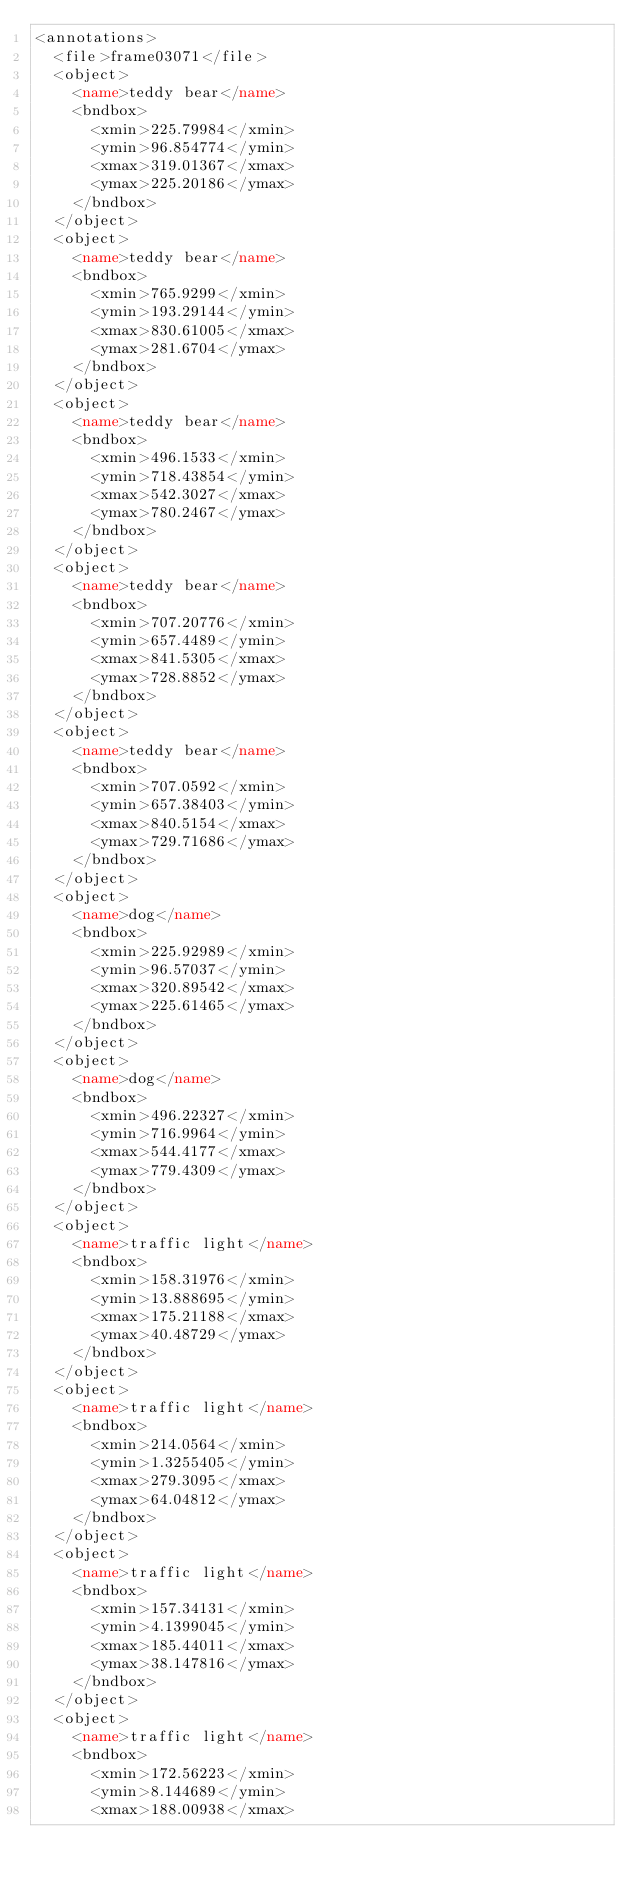<code> <loc_0><loc_0><loc_500><loc_500><_XML_><annotations>
  <file>frame03071</file>
  <object>
    <name>teddy bear</name>
    <bndbox>
      <xmin>225.79984</xmin>
      <ymin>96.854774</ymin>
      <xmax>319.01367</xmax>
      <ymax>225.20186</ymax>
    </bndbox>
  </object>
  <object>
    <name>teddy bear</name>
    <bndbox>
      <xmin>765.9299</xmin>
      <ymin>193.29144</ymin>
      <xmax>830.61005</xmax>
      <ymax>281.6704</ymax>
    </bndbox>
  </object>
  <object>
    <name>teddy bear</name>
    <bndbox>
      <xmin>496.1533</xmin>
      <ymin>718.43854</ymin>
      <xmax>542.3027</xmax>
      <ymax>780.2467</ymax>
    </bndbox>
  </object>
  <object>
    <name>teddy bear</name>
    <bndbox>
      <xmin>707.20776</xmin>
      <ymin>657.4489</ymin>
      <xmax>841.5305</xmax>
      <ymax>728.8852</ymax>
    </bndbox>
  </object>
  <object>
    <name>teddy bear</name>
    <bndbox>
      <xmin>707.0592</xmin>
      <ymin>657.38403</ymin>
      <xmax>840.5154</xmax>
      <ymax>729.71686</ymax>
    </bndbox>
  </object>
  <object>
    <name>dog</name>
    <bndbox>
      <xmin>225.92989</xmin>
      <ymin>96.57037</ymin>
      <xmax>320.89542</xmax>
      <ymax>225.61465</ymax>
    </bndbox>
  </object>
  <object>
    <name>dog</name>
    <bndbox>
      <xmin>496.22327</xmin>
      <ymin>716.9964</ymin>
      <xmax>544.4177</xmax>
      <ymax>779.4309</ymax>
    </bndbox>
  </object>
  <object>
    <name>traffic light</name>
    <bndbox>
      <xmin>158.31976</xmin>
      <ymin>13.888695</ymin>
      <xmax>175.21188</xmax>
      <ymax>40.48729</ymax>
    </bndbox>
  </object>
  <object>
    <name>traffic light</name>
    <bndbox>
      <xmin>214.0564</xmin>
      <ymin>1.3255405</ymin>
      <xmax>279.3095</xmax>
      <ymax>64.04812</ymax>
    </bndbox>
  </object>
  <object>
    <name>traffic light</name>
    <bndbox>
      <xmin>157.34131</xmin>
      <ymin>4.1399045</ymin>
      <xmax>185.44011</xmax>
      <ymax>38.147816</ymax>
    </bndbox>
  </object>
  <object>
    <name>traffic light</name>
    <bndbox>
      <xmin>172.56223</xmin>
      <ymin>8.144689</ymin>
      <xmax>188.00938</xmax></code> 